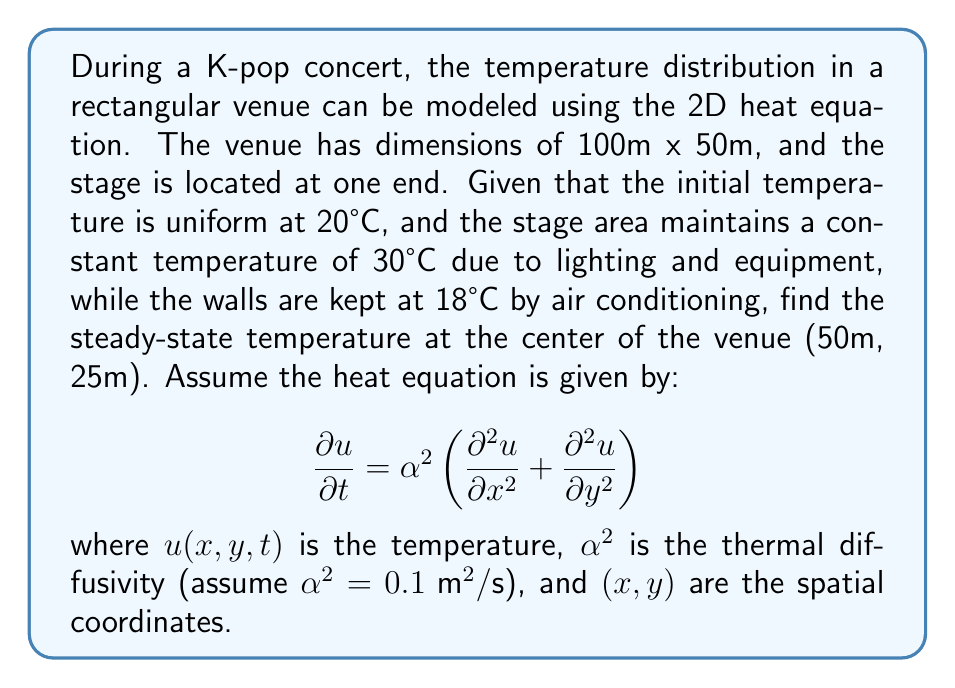Teach me how to tackle this problem. To solve this problem, we need to consider the steady-state solution of the heat equation, which occurs when the temperature no longer changes with time. In this case, we set $\frac{\partial u}{\partial t} = 0$, resulting in:

$$0 = \alpha^2 \left(\frac{\partial^2 u}{\partial x^2} + \frac{\partial^2 u}{\partial y^2}\right)$$

This simplifies to Laplace's equation:

$$\frac{\partial^2 u}{\partial x^2} + \frac{\partial^2 u}{\partial y^2} = 0$$

Given the rectangular shape and boundary conditions, we can use the method of separation of variables. The solution will have the form:

$$u(x,y) = \sum_{n=1}^{\infty} A_n \sinh(\frac{n\pi x}{L_y}) \sin(\frac{n\pi y}{L_y})$$

where $L_x = 100\text{ m}$ and $L_y = 50\text{ m}$.

The coefficients $A_n$ are determined by the boundary conditions:

1. $u(0,y) = 30°C$ (stage)
2. $u(L_x,y) = 18°C$ (back wall)
3. $u(x,0) = u(x,L_y) = 18°C$ (side walls)

After applying these conditions and solving for $A_n$, we get:

$$A_n = \frac{2}{L_y \sinh(\frac{n\pi L_x}{L_y})} \left[ (30-18) \sin(\frac{n\pi y}{L_y}) dy - (18-18) \sin(\frac{n\pi y}{L_y}) dy \right]$$

$$A_n = \frac{24}{n\pi \sinh(2n\pi)} (1 - (-1)^n)$$

The steady-state temperature at the center (50m, 25m) can be calculated by evaluating the series:

$$u(50,25) = \sum_{n=1}^{\infty} \frac{24}{n\pi \sinh(2n\pi)} (1 - (-1)^n) \sinh(n\pi) \sin(\frac{n\pi}{2})$$

In practice, we can approximate this sum by taking the first few terms (e.g., n = 1 to 5) for a reasonably accurate result.
Answer: The steady-state temperature at the center of the venue (50m, 25m) is approximately 22.8°C. 